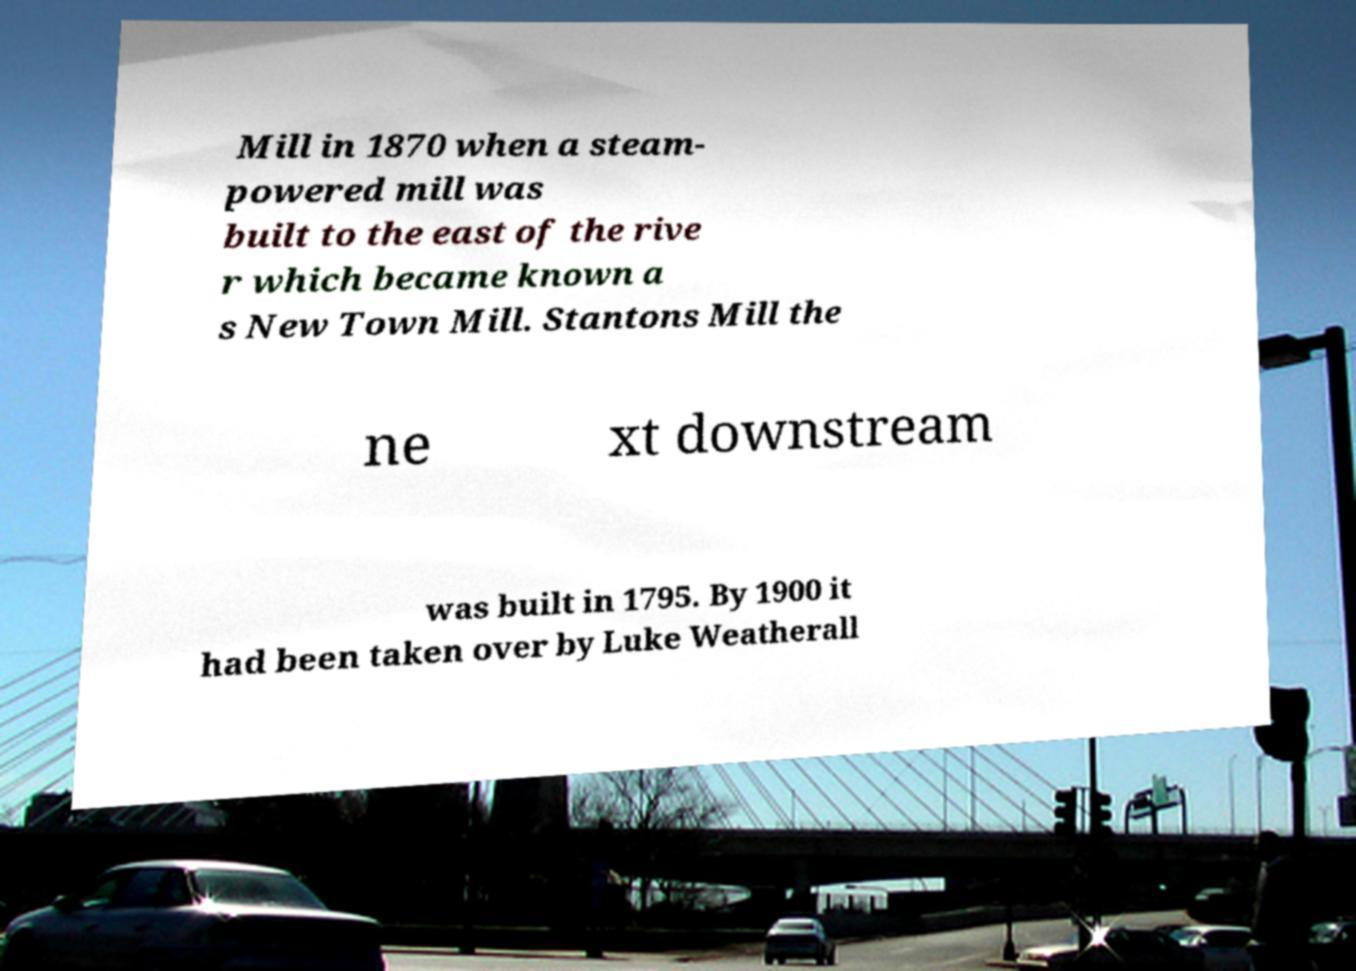Can you read and provide the text displayed in the image?This photo seems to have some interesting text. Can you extract and type it out for me? Mill in 1870 when a steam- powered mill was built to the east of the rive r which became known a s New Town Mill. Stantons Mill the ne xt downstream was built in 1795. By 1900 it had been taken over by Luke Weatherall 